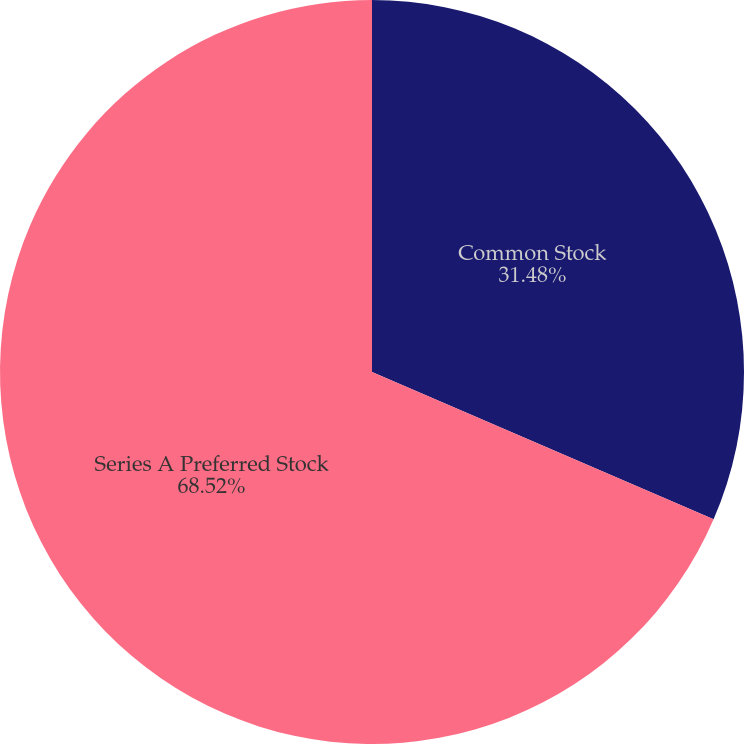Convert chart to OTSL. <chart><loc_0><loc_0><loc_500><loc_500><pie_chart><fcel>Common Stock<fcel>Series A Preferred Stock<nl><fcel>31.48%<fcel>68.52%<nl></chart> 